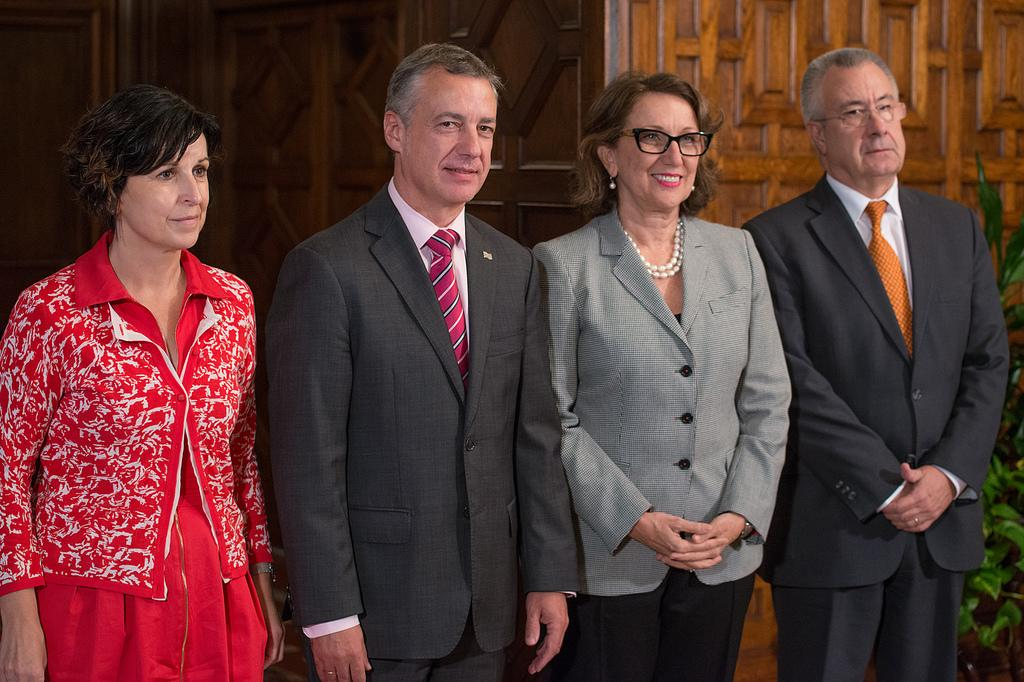How many people are in the image? There are four persons in the image. What are the persons doing in the image? The persons are standing and smiling. What can be seen in the background of the image? There is a wooden wall in the background of the image. Where is the plant located in the image? The plant is in the right corner of the image. What type of store can be seen in the image? There is no store present in the image. What is the size of the mother in the image? There is no mother present in the image, so it is not possible to determine her size. 